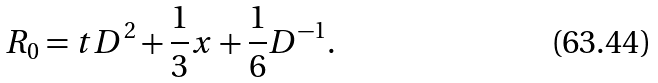Convert formula to latex. <formula><loc_0><loc_0><loc_500><loc_500>R _ { 0 } = t D ^ { 2 } + { \frac { 1 } { 3 } } x + { \frac { 1 } { 6 } } D ^ { - 1 } .</formula> 